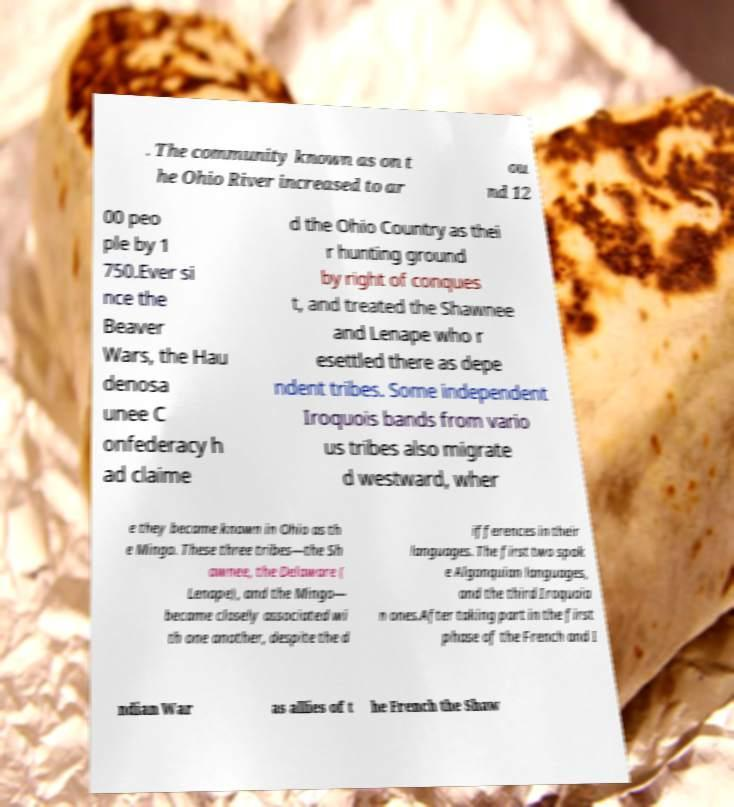I need the written content from this picture converted into text. Can you do that? . The community known as on t he Ohio River increased to ar ou nd 12 00 peo ple by 1 750.Ever si nce the Beaver Wars, the Hau denosa unee C onfederacy h ad claime d the Ohio Country as thei r hunting ground by right of conques t, and treated the Shawnee and Lenape who r esettled there as depe ndent tribes. Some independent Iroquois bands from vario us tribes also migrate d westward, wher e they became known in Ohio as th e Mingo. These three tribes—the Sh awnee, the Delaware ( Lenape), and the Mingo— became closely associated wi th one another, despite the d ifferences in their languages. The first two spok e Algonquian languages, and the third Iroquoia n ones.After taking part in the first phase of the French and I ndian War as allies of t he French the Shaw 